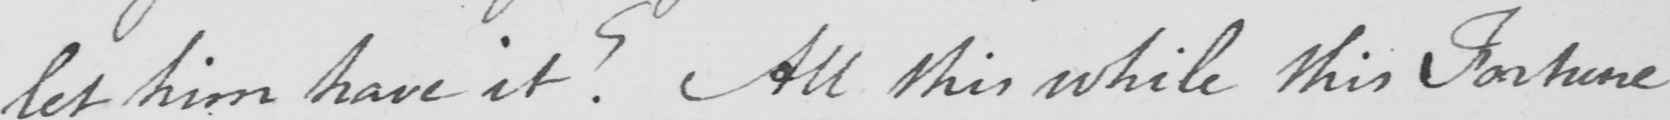Please transcribe the handwritten text in this image. let him have it ?  All this while this Fortune 